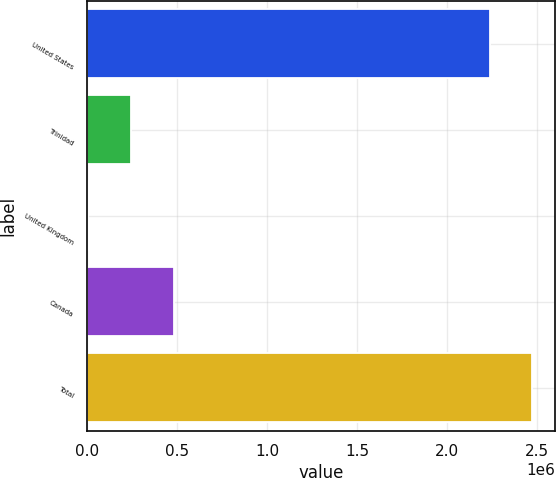Convert chart. <chart><loc_0><loc_0><loc_500><loc_500><bar_chart><fcel>United States<fcel>Trinidad<fcel>United Kingdom<fcel>Canada<fcel>Total<nl><fcel>2.2369e+06<fcel>241663<fcel>4248<fcel>479079<fcel>2.47432e+06<nl></chart> 